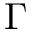<formula> <loc_0><loc_0><loc_500><loc_500>\Gamma</formula> 